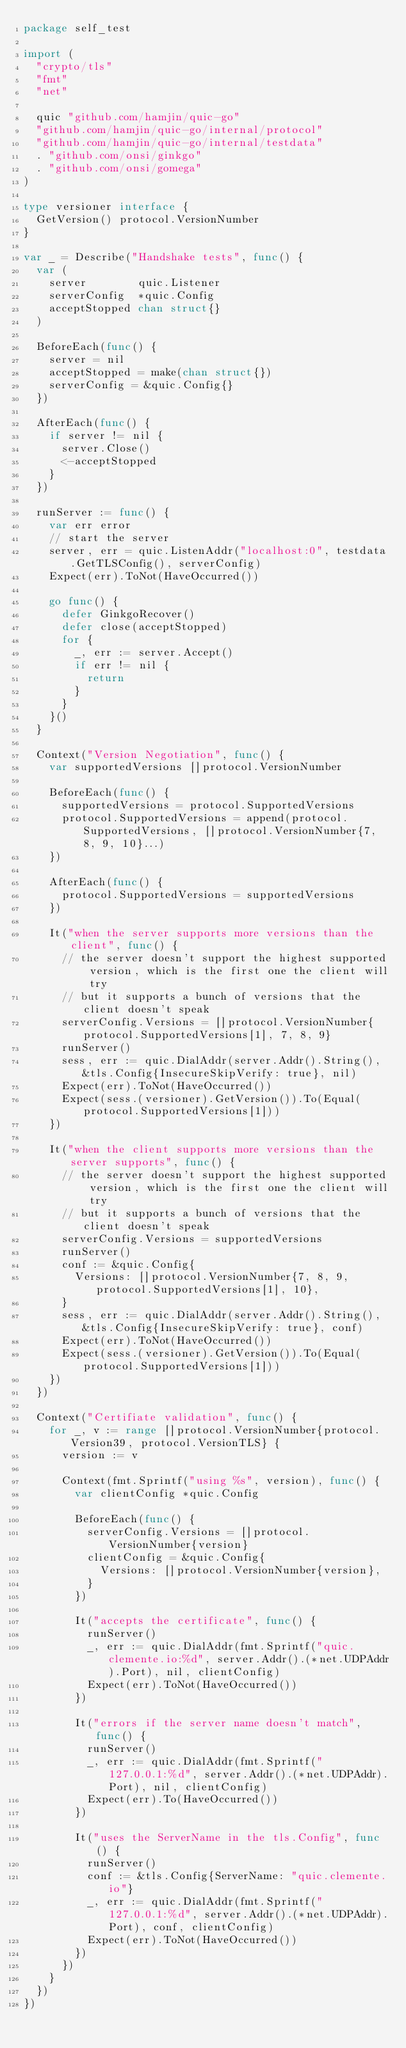Convert code to text. <code><loc_0><loc_0><loc_500><loc_500><_Go_>package self_test

import (
	"crypto/tls"
	"fmt"
	"net"

	quic "github.com/hamjin/quic-go"
	"github.com/hamjin/quic-go/internal/protocol"
	"github.com/hamjin/quic-go/internal/testdata"
	. "github.com/onsi/ginkgo"
	. "github.com/onsi/gomega"
)

type versioner interface {
	GetVersion() protocol.VersionNumber
}

var _ = Describe("Handshake tests", func() {
	var (
		server        quic.Listener
		serverConfig  *quic.Config
		acceptStopped chan struct{}
	)

	BeforeEach(func() {
		server = nil
		acceptStopped = make(chan struct{})
		serverConfig = &quic.Config{}
	})

	AfterEach(func() {
		if server != nil {
			server.Close()
			<-acceptStopped
		}
	})

	runServer := func() {
		var err error
		// start the server
		server, err = quic.ListenAddr("localhost:0", testdata.GetTLSConfig(), serverConfig)
		Expect(err).ToNot(HaveOccurred())

		go func() {
			defer GinkgoRecover()
			defer close(acceptStopped)
			for {
				_, err := server.Accept()
				if err != nil {
					return
				}
			}
		}()
	}

	Context("Version Negotiation", func() {
		var supportedVersions []protocol.VersionNumber

		BeforeEach(func() {
			supportedVersions = protocol.SupportedVersions
			protocol.SupportedVersions = append(protocol.SupportedVersions, []protocol.VersionNumber{7, 8, 9, 10}...)
		})

		AfterEach(func() {
			protocol.SupportedVersions = supportedVersions
		})

		It("when the server supports more versions than the client", func() {
			// the server doesn't support the highest supported version, which is the first one the client will try
			// but it supports a bunch of versions that the client doesn't speak
			serverConfig.Versions = []protocol.VersionNumber{protocol.SupportedVersions[1], 7, 8, 9}
			runServer()
			sess, err := quic.DialAddr(server.Addr().String(), &tls.Config{InsecureSkipVerify: true}, nil)
			Expect(err).ToNot(HaveOccurred())
			Expect(sess.(versioner).GetVersion()).To(Equal(protocol.SupportedVersions[1]))
		})

		It("when the client supports more versions than the server supports", func() {
			// the server doesn't support the highest supported version, which is the first one the client will try
			// but it supports a bunch of versions that the client doesn't speak
			serverConfig.Versions = supportedVersions
			runServer()
			conf := &quic.Config{
				Versions: []protocol.VersionNumber{7, 8, 9, protocol.SupportedVersions[1], 10},
			}
			sess, err := quic.DialAddr(server.Addr().String(), &tls.Config{InsecureSkipVerify: true}, conf)
			Expect(err).ToNot(HaveOccurred())
			Expect(sess.(versioner).GetVersion()).To(Equal(protocol.SupportedVersions[1]))
		})
	})

	Context("Certifiate validation", func() {
		for _, v := range []protocol.VersionNumber{protocol.Version39, protocol.VersionTLS} {
			version := v

			Context(fmt.Sprintf("using %s", version), func() {
				var clientConfig *quic.Config

				BeforeEach(func() {
					serverConfig.Versions = []protocol.VersionNumber{version}
					clientConfig = &quic.Config{
						Versions: []protocol.VersionNumber{version},
					}
				})

				It("accepts the certificate", func() {
					runServer()
					_, err := quic.DialAddr(fmt.Sprintf("quic.clemente.io:%d", server.Addr().(*net.UDPAddr).Port), nil, clientConfig)
					Expect(err).ToNot(HaveOccurred())
				})

				It("errors if the server name doesn't match", func() {
					runServer()
					_, err := quic.DialAddr(fmt.Sprintf("127.0.0.1:%d", server.Addr().(*net.UDPAddr).Port), nil, clientConfig)
					Expect(err).To(HaveOccurred())
				})

				It("uses the ServerName in the tls.Config", func() {
					runServer()
					conf := &tls.Config{ServerName: "quic.clemente.io"}
					_, err := quic.DialAddr(fmt.Sprintf("127.0.0.1:%d", server.Addr().(*net.UDPAddr).Port), conf, clientConfig)
					Expect(err).ToNot(HaveOccurred())
				})
			})
		}
	})
})
</code> 